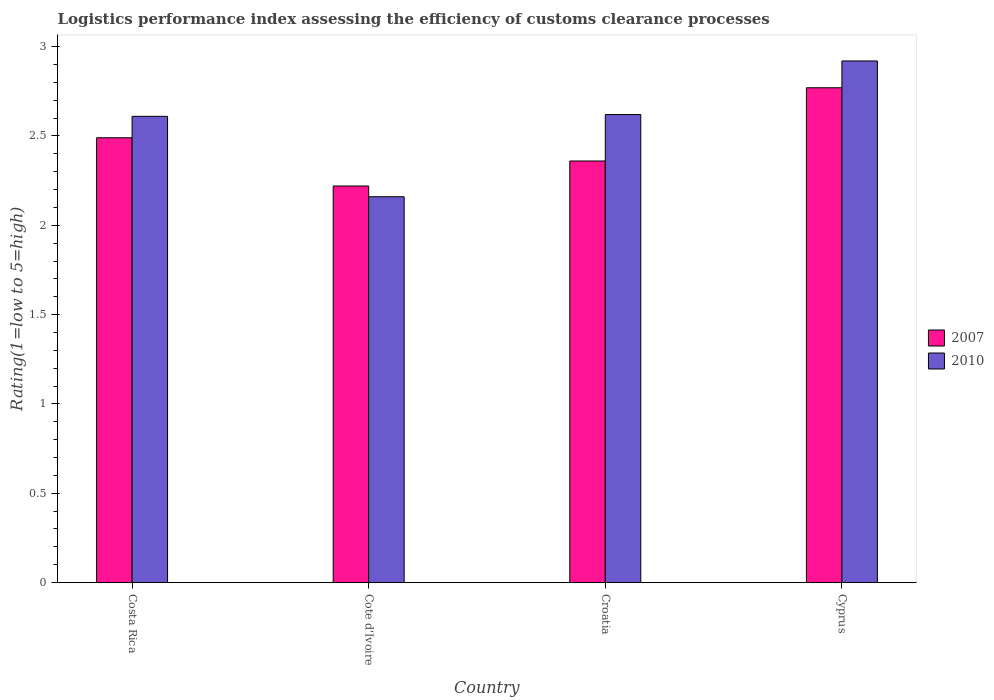How many different coloured bars are there?
Keep it short and to the point. 2. Are the number of bars on each tick of the X-axis equal?
Ensure brevity in your answer.  Yes. How many bars are there on the 1st tick from the left?
Provide a short and direct response. 2. What is the label of the 3rd group of bars from the left?
Ensure brevity in your answer.  Croatia. What is the Logistic performance index in 2007 in Cote d'Ivoire?
Keep it short and to the point. 2.22. Across all countries, what is the maximum Logistic performance index in 2010?
Give a very brief answer. 2.92. Across all countries, what is the minimum Logistic performance index in 2007?
Provide a short and direct response. 2.22. In which country was the Logistic performance index in 2007 maximum?
Make the answer very short. Cyprus. In which country was the Logistic performance index in 2010 minimum?
Your response must be concise. Cote d'Ivoire. What is the total Logistic performance index in 2010 in the graph?
Provide a succinct answer. 10.31. What is the difference between the Logistic performance index in 2010 in Costa Rica and that in Croatia?
Your answer should be compact. -0.01. What is the difference between the Logistic performance index in 2007 in Croatia and the Logistic performance index in 2010 in Cyprus?
Provide a succinct answer. -0.56. What is the average Logistic performance index in 2010 per country?
Offer a terse response. 2.58. What is the difference between the Logistic performance index of/in 2010 and Logistic performance index of/in 2007 in Croatia?
Ensure brevity in your answer.  0.26. What is the ratio of the Logistic performance index in 2010 in Cote d'Ivoire to that in Cyprus?
Keep it short and to the point. 0.74. Is the Logistic performance index in 2010 in Croatia less than that in Cyprus?
Keep it short and to the point. Yes. Is the difference between the Logistic performance index in 2010 in Costa Rica and Cote d'Ivoire greater than the difference between the Logistic performance index in 2007 in Costa Rica and Cote d'Ivoire?
Provide a succinct answer. Yes. What is the difference between the highest and the second highest Logistic performance index in 2007?
Give a very brief answer. -0.41. What is the difference between the highest and the lowest Logistic performance index in 2010?
Provide a succinct answer. 0.76. In how many countries, is the Logistic performance index in 2007 greater than the average Logistic performance index in 2007 taken over all countries?
Keep it short and to the point. 2. Is the sum of the Logistic performance index in 2007 in Costa Rica and Croatia greater than the maximum Logistic performance index in 2010 across all countries?
Provide a short and direct response. Yes. What does the 1st bar from the right in Cote d'Ivoire represents?
Give a very brief answer. 2010. How many bars are there?
Keep it short and to the point. 8. Are all the bars in the graph horizontal?
Offer a very short reply. No. Are the values on the major ticks of Y-axis written in scientific E-notation?
Keep it short and to the point. No. Does the graph contain grids?
Ensure brevity in your answer.  No. How many legend labels are there?
Provide a short and direct response. 2. How are the legend labels stacked?
Provide a short and direct response. Vertical. What is the title of the graph?
Your answer should be very brief. Logistics performance index assessing the efficiency of customs clearance processes. Does "2005" appear as one of the legend labels in the graph?
Your answer should be compact. No. What is the label or title of the Y-axis?
Your answer should be very brief. Rating(1=low to 5=high). What is the Rating(1=low to 5=high) of 2007 in Costa Rica?
Ensure brevity in your answer.  2.49. What is the Rating(1=low to 5=high) of 2010 in Costa Rica?
Make the answer very short. 2.61. What is the Rating(1=low to 5=high) in 2007 in Cote d'Ivoire?
Ensure brevity in your answer.  2.22. What is the Rating(1=low to 5=high) in 2010 in Cote d'Ivoire?
Ensure brevity in your answer.  2.16. What is the Rating(1=low to 5=high) in 2007 in Croatia?
Give a very brief answer. 2.36. What is the Rating(1=low to 5=high) of 2010 in Croatia?
Your answer should be compact. 2.62. What is the Rating(1=low to 5=high) in 2007 in Cyprus?
Provide a succinct answer. 2.77. What is the Rating(1=low to 5=high) in 2010 in Cyprus?
Your answer should be very brief. 2.92. Across all countries, what is the maximum Rating(1=low to 5=high) in 2007?
Your response must be concise. 2.77. Across all countries, what is the maximum Rating(1=low to 5=high) in 2010?
Provide a succinct answer. 2.92. Across all countries, what is the minimum Rating(1=low to 5=high) of 2007?
Your answer should be very brief. 2.22. Across all countries, what is the minimum Rating(1=low to 5=high) in 2010?
Your response must be concise. 2.16. What is the total Rating(1=low to 5=high) in 2007 in the graph?
Offer a very short reply. 9.84. What is the total Rating(1=low to 5=high) of 2010 in the graph?
Your answer should be compact. 10.31. What is the difference between the Rating(1=low to 5=high) in 2007 in Costa Rica and that in Cote d'Ivoire?
Ensure brevity in your answer.  0.27. What is the difference between the Rating(1=low to 5=high) of 2010 in Costa Rica and that in Cote d'Ivoire?
Ensure brevity in your answer.  0.45. What is the difference between the Rating(1=low to 5=high) of 2007 in Costa Rica and that in Croatia?
Your answer should be very brief. 0.13. What is the difference between the Rating(1=low to 5=high) of 2010 in Costa Rica and that in Croatia?
Provide a succinct answer. -0.01. What is the difference between the Rating(1=low to 5=high) of 2007 in Costa Rica and that in Cyprus?
Offer a very short reply. -0.28. What is the difference between the Rating(1=low to 5=high) of 2010 in Costa Rica and that in Cyprus?
Provide a short and direct response. -0.31. What is the difference between the Rating(1=low to 5=high) in 2007 in Cote d'Ivoire and that in Croatia?
Provide a short and direct response. -0.14. What is the difference between the Rating(1=low to 5=high) in 2010 in Cote d'Ivoire and that in Croatia?
Your answer should be very brief. -0.46. What is the difference between the Rating(1=low to 5=high) of 2007 in Cote d'Ivoire and that in Cyprus?
Make the answer very short. -0.55. What is the difference between the Rating(1=low to 5=high) of 2010 in Cote d'Ivoire and that in Cyprus?
Your response must be concise. -0.76. What is the difference between the Rating(1=low to 5=high) of 2007 in Croatia and that in Cyprus?
Your response must be concise. -0.41. What is the difference between the Rating(1=low to 5=high) of 2007 in Costa Rica and the Rating(1=low to 5=high) of 2010 in Cote d'Ivoire?
Offer a terse response. 0.33. What is the difference between the Rating(1=low to 5=high) in 2007 in Costa Rica and the Rating(1=low to 5=high) in 2010 in Croatia?
Your answer should be very brief. -0.13. What is the difference between the Rating(1=low to 5=high) of 2007 in Costa Rica and the Rating(1=low to 5=high) of 2010 in Cyprus?
Provide a short and direct response. -0.43. What is the difference between the Rating(1=low to 5=high) of 2007 in Cote d'Ivoire and the Rating(1=low to 5=high) of 2010 in Croatia?
Offer a very short reply. -0.4. What is the difference between the Rating(1=low to 5=high) in 2007 in Croatia and the Rating(1=low to 5=high) in 2010 in Cyprus?
Give a very brief answer. -0.56. What is the average Rating(1=low to 5=high) of 2007 per country?
Provide a short and direct response. 2.46. What is the average Rating(1=low to 5=high) of 2010 per country?
Give a very brief answer. 2.58. What is the difference between the Rating(1=low to 5=high) of 2007 and Rating(1=low to 5=high) of 2010 in Costa Rica?
Ensure brevity in your answer.  -0.12. What is the difference between the Rating(1=low to 5=high) of 2007 and Rating(1=low to 5=high) of 2010 in Cote d'Ivoire?
Ensure brevity in your answer.  0.06. What is the difference between the Rating(1=low to 5=high) in 2007 and Rating(1=low to 5=high) in 2010 in Croatia?
Keep it short and to the point. -0.26. What is the ratio of the Rating(1=low to 5=high) of 2007 in Costa Rica to that in Cote d'Ivoire?
Your response must be concise. 1.12. What is the ratio of the Rating(1=low to 5=high) in 2010 in Costa Rica to that in Cote d'Ivoire?
Provide a succinct answer. 1.21. What is the ratio of the Rating(1=low to 5=high) of 2007 in Costa Rica to that in Croatia?
Your answer should be very brief. 1.06. What is the ratio of the Rating(1=low to 5=high) in 2010 in Costa Rica to that in Croatia?
Make the answer very short. 1. What is the ratio of the Rating(1=low to 5=high) in 2007 in Costa Rica to that in Cyprus?
Provide a succinct answer. 0.9. What is the ratio of the Rating(1=low to 5=high) of 2010 in Costa Rica to that in Cyprus?
Provide a succinct answer. 0.89. What is the ratio of the Rating(1=low to 5=high) of 2007 in Cote d'Ivoire to that in Croatia?
Keep it short and to the point. 0.94. What is the ratio of the Rating(1=low to 5=high) in 2010 in Cote d'Ivoire to that in Croatia?
Your answer should be compact. 0.82. What is the ratio of the Rating(1=low to 5=high) in 2007 in Cote d'Ivoire to that in Cyprus?
Give a very brief answer. 0.8. What is the ratio of the Rating(1=low to 5=high) of 2010 in Cote d'Ivoire to that in Cyprus?
Ensure brevity in your answer.  0.74. What is the ratio of the Rating(1=low to 5=high) in 2007 in Croatia to that in Cyprus?
Keep it short and to the point. 0.85. What is the ratio of the Rating(1=low to 5=high) in 2010 in Croatia to that in Cyprus?
Keep it short and to the point. 0.9. What is the difference between the highest and the second highest Rating(1=low to 5=high) of 2007?
Your response must be concise. 0.28. What is the difference between the highest and the second highest Rating(1=low to 5=high) in 2010?
Your response must be concise. 0.3. What is the difference between the highest and the lowest Rating(1=low to 5=high) of 2007?
Your answer should be very brief. 0.55. What is the difference between the highest and the lowest Rating(1=low to 5=high) in 2010?
Keep it short and to the point. 0.76. 